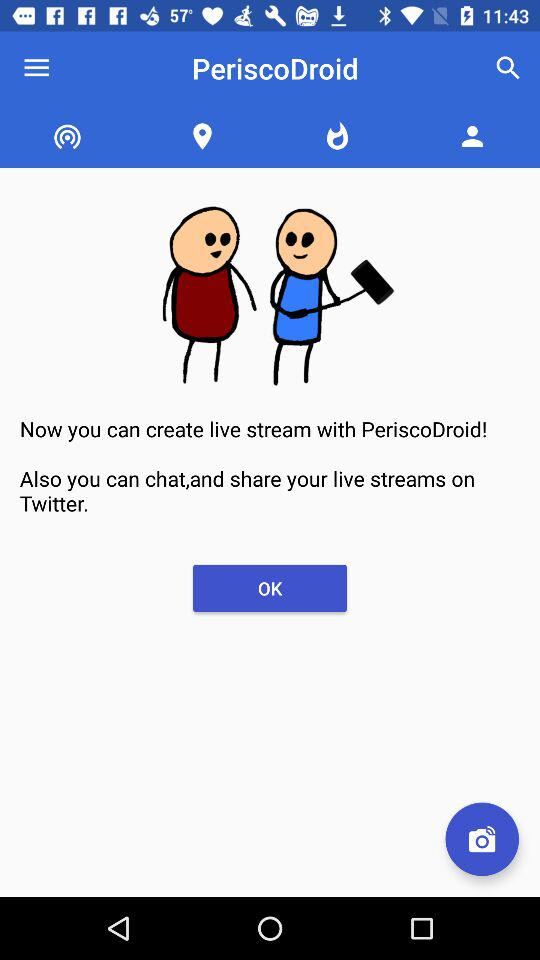What is the name of the application? The name of the application is "PeriscoDroid". 